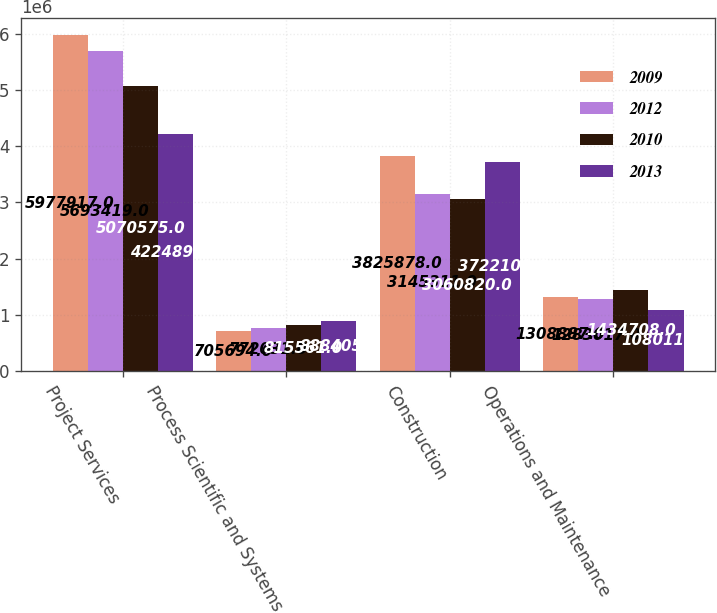Convert chart. <chart><loc_0><loc_0><loc_500><loc_500><stacked_bar_chart><ecel><fcel>Project Services<fcel>Process Scientific and Systems<fcel>Construction<fcel>Operations and Maintenance<nl><fcel>2009<fcel>5.97792e+06<fcel>705694<fcel>3.82588e+06<fcel>1.30889e+06<nl><fcel>2012<fcel>5.69342e+06<fcel>772031<fcel>3.14531e+06<fcel>1.28302e+06<nl><fcel>2010<fcel>5.07058e+06<fcel>815561<fcel>3.06082e+06<fcel>1.43471e+06<nl><fcel>2013<fcel>4.2249e+06<fcel>888405<fcel>3.7221e+06<fcel>1.08011e+06<nl></chart> 